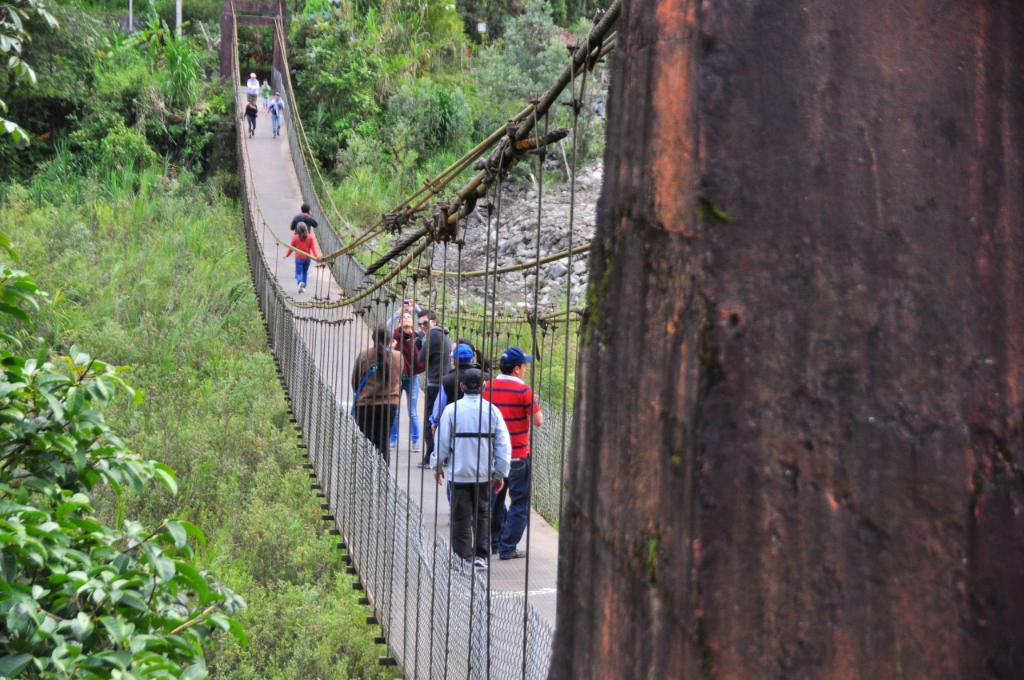What is the main object in the foreground of the image? There is a tree trunk in the image. What can be seen in the middle of the image? There is a group of people on a bridge in the image. What type of natural environment is visible in the background of the image? There are trees and soil visible in the background of the image. What architectural features can be seen in the background of the image? There are poles in the background of the image. What type of lead is being used by the sister in the image? There is no sister or lead present in the image. What type of flag is being waved by the people on the bridge in the image? There is no flag visible in the image; only a group of people on a bridge is present. 